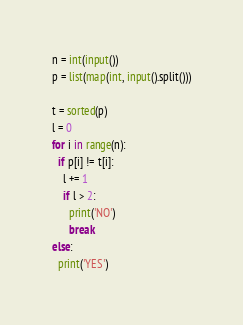<code> <loc_0><loc_0><loc_500><loc_500><_Python_>n = int(input())
p = list(map(int, input().split()))

t = sorted(p)
l = 0
for i in range(n):
  if p[i] != t[i]:
    l += 1
    if l > 2:
      print('NO')
      break
else:
  print('YES')</code> 